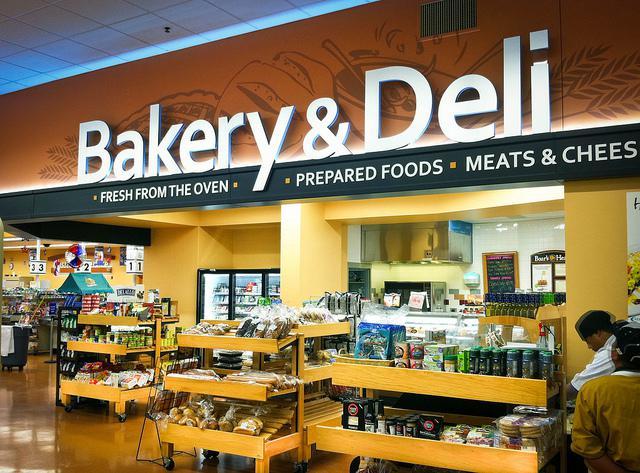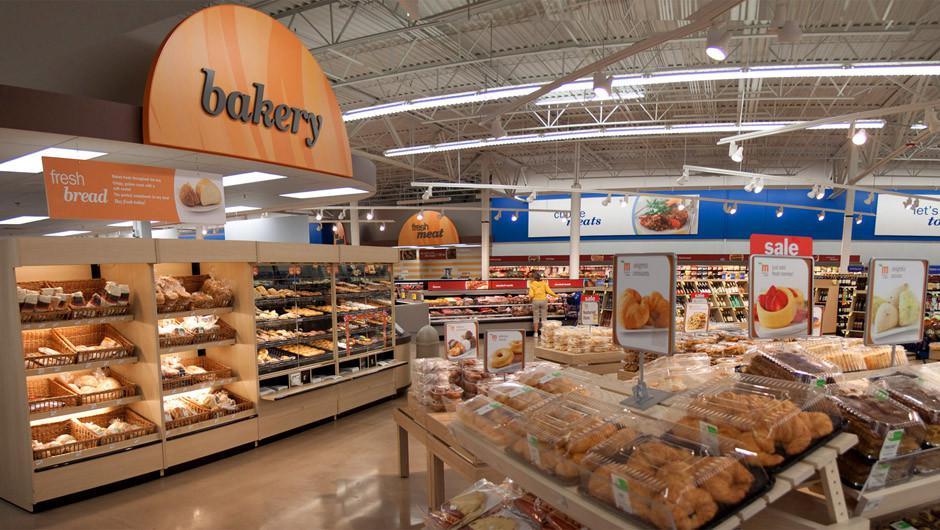The first image is the image on the left, the second image is the image on the right. Evaluate the accuracy of this statement regarding the images: "In the store there are labels to show a combine bakery and deli.". Is it true? Answer yes or no. Yes. The first image is the image on the left, the second image is the image on the right. Given the left and right images, does the statement "The bakery sign is in a frame with a rounded top." hold true? Answer yes or no. Yes. 